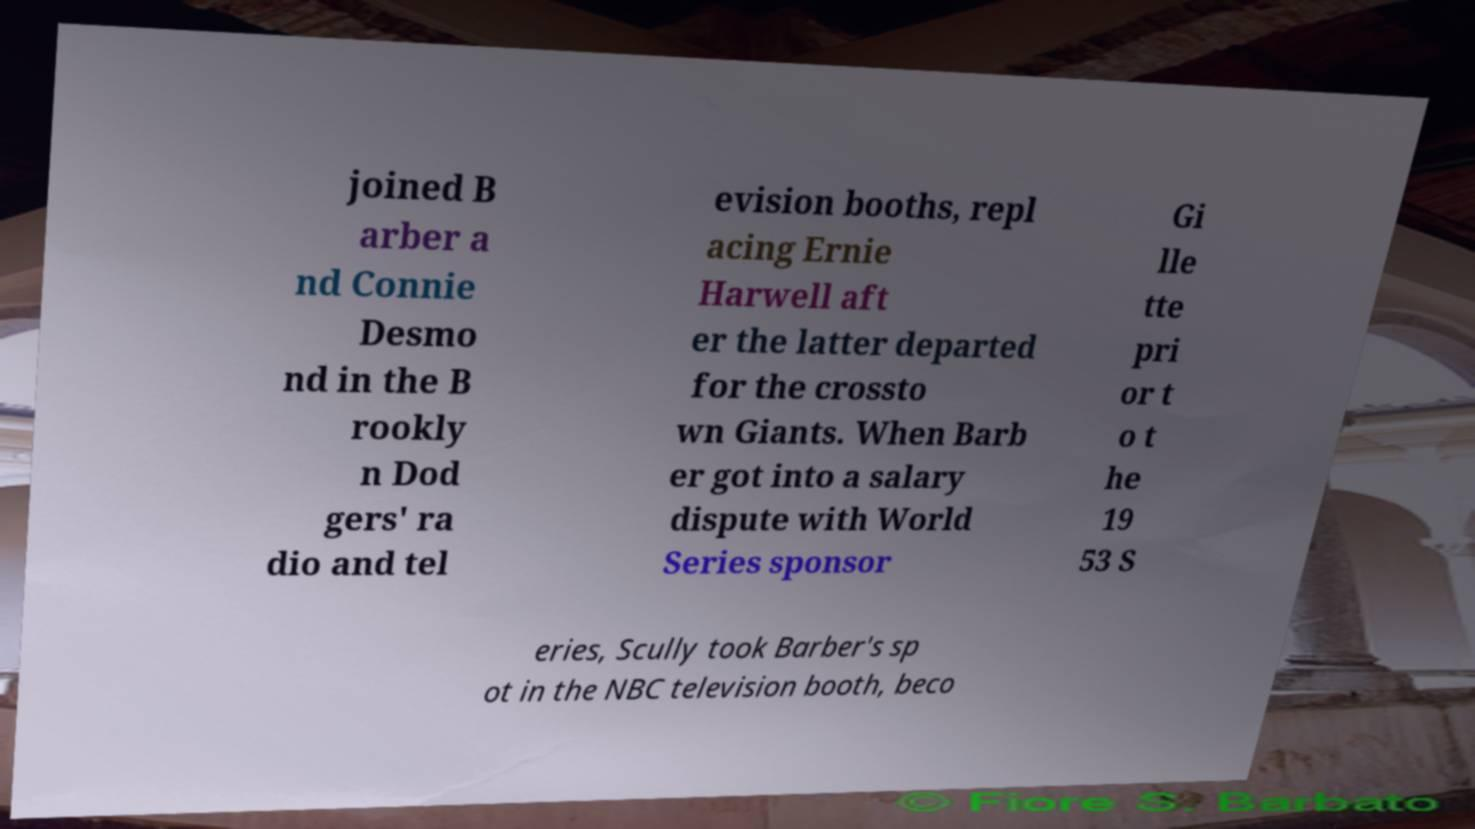I need the written content from this picture converted into text. Can you do that? joined B arber a nd Connie Desmo nd in the B rookly n Dod gers' ra dio and tel evision booths, repl acing Ernie Harwell aft er the latter departed for the crossto wn Giants. When Barb er got into a salary dispute with World Series sponsor Gi lle tte pri or t o t he 19 53 S eries, Scully took Barber's sp ot in the NBC television booth, beco 